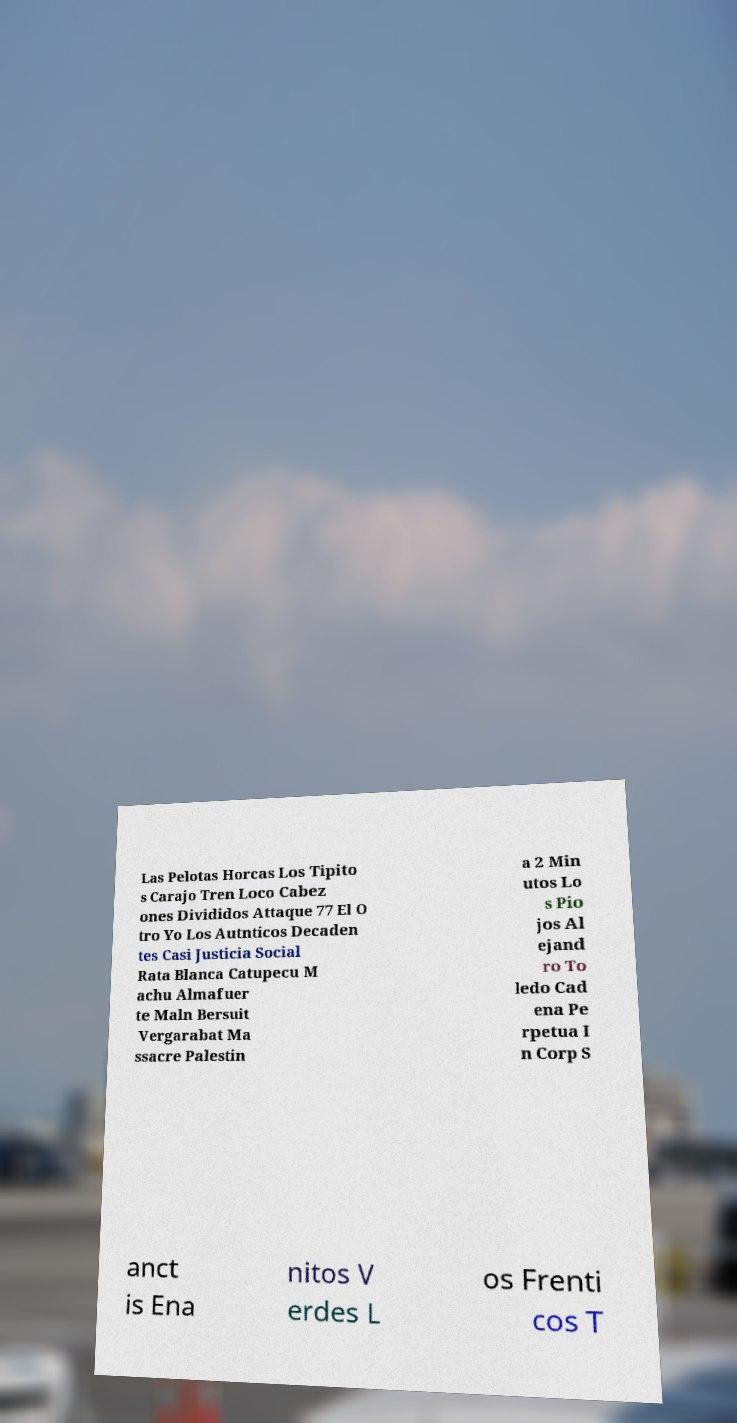Please identify and transcribe the text found in this image. Las Pelotas Horcas Los Tipito s Carajo Tren Loco Cabez ones Divididos Attaque 77 El O tro Yo Los Autnticos Decaden tes Casi Justicia Social Rata Blanca Catupecu M achu Almafuer te Maln Bersuit Vergarabat Ma ssacre Palestin a 2 Min utos Lo s Pio jos Al ejand ro To ledo Cad ena Pe rpetua I n Corp S anct is Ena nitos V erdes L os Frenti cos T 